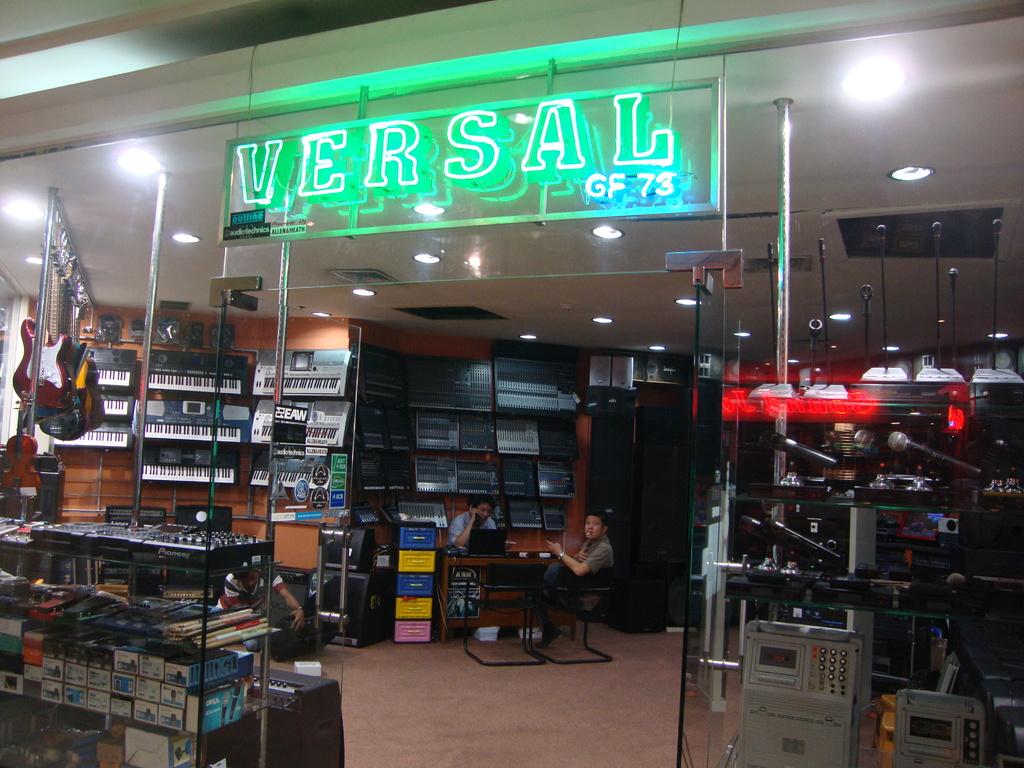Does this store sell guitars?
Give a very brief answer. Yes. What is the name of the store?
Offer a very short reply. Versal. 